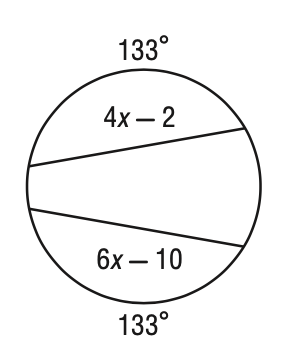Question: Solve for x in the figure.
Choices:
A. 2
B. 3
C. 4
D. 6
Answer with the letter. Answer: C 